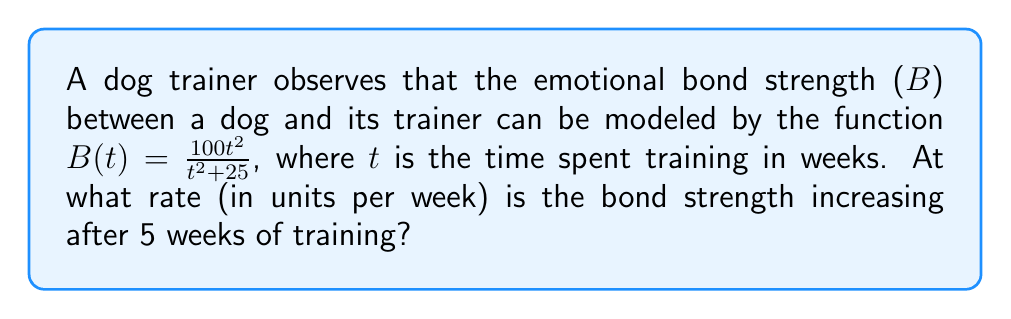Could you help me with this problem? To find the rate at which the bond strength is increasing after 5 weeks, we need to calculate the derivative of B(t) and evaluate it at t = 5.

Step 1: Calculate the derivative of B(t) using the quotient rule.
$$\frac{d}{dt}B(t) = \frac{d}{dt}\left(\frac{100t^2}{t^2 + 25}\right)$$
$$B'(t) = \frac{(t^2 + 25)(200t) - 100t^2(2t)}{(t^2 + 25)^2}$$

Step 2: Simplify the derivative.
$$B'(t) = \frac{200t^3 + 5000t - 200t^3}{(t^2 + 25)^2}$$
$$B'(t) = \frac{5000t}{(t^2 + 25)^2}$$

Step 3: Evaluate B'(t) at t = 5.
$$B'(5) = \frac{5000(5)}{(5^2 + 25)^2}$$
$$B'(5) = \frac{25000}{(25 + 25)^2}$$
$$B'(5) = \frac{25000}{2500}$$
$$B'(5) = 10$$

Therefore, after 5 weeks of training, the bond strength is increasing at a rate of 10 units per week.
Answer: 10 units per week 